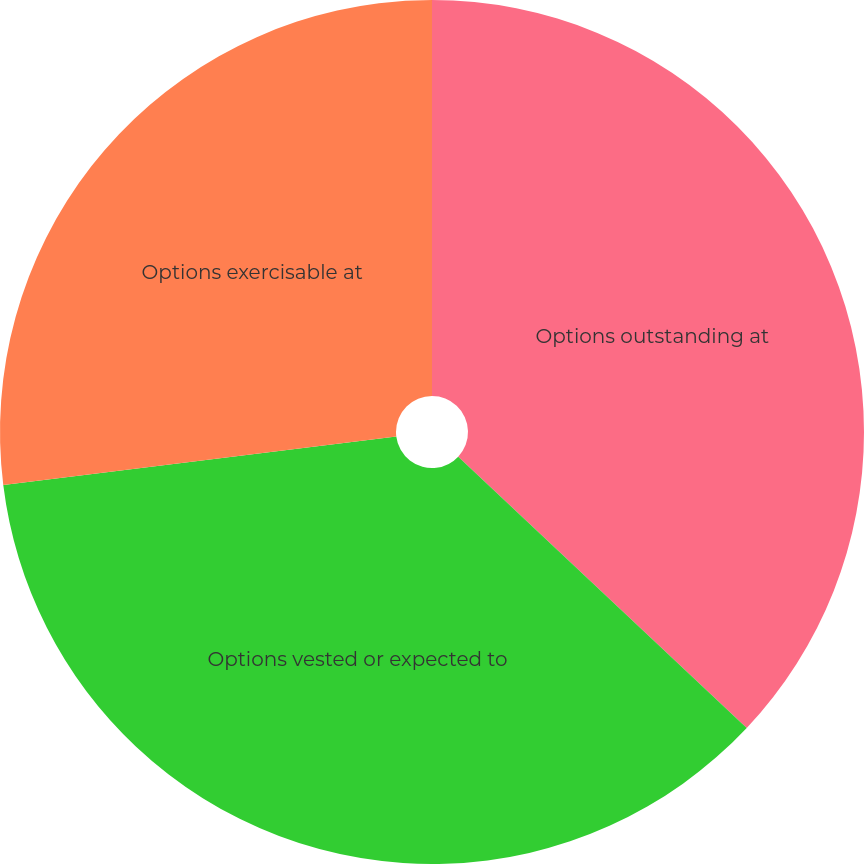<chart> <loc_0><loc_0><loc_500><loc_500><pie_chart><fcel>Options outstanding at<fcel>Options vested or expected to<fcel>Options exercisable at<nl><fcel>37.01%<fcel>36.03%<fcel>26.96%<nl></chart> 